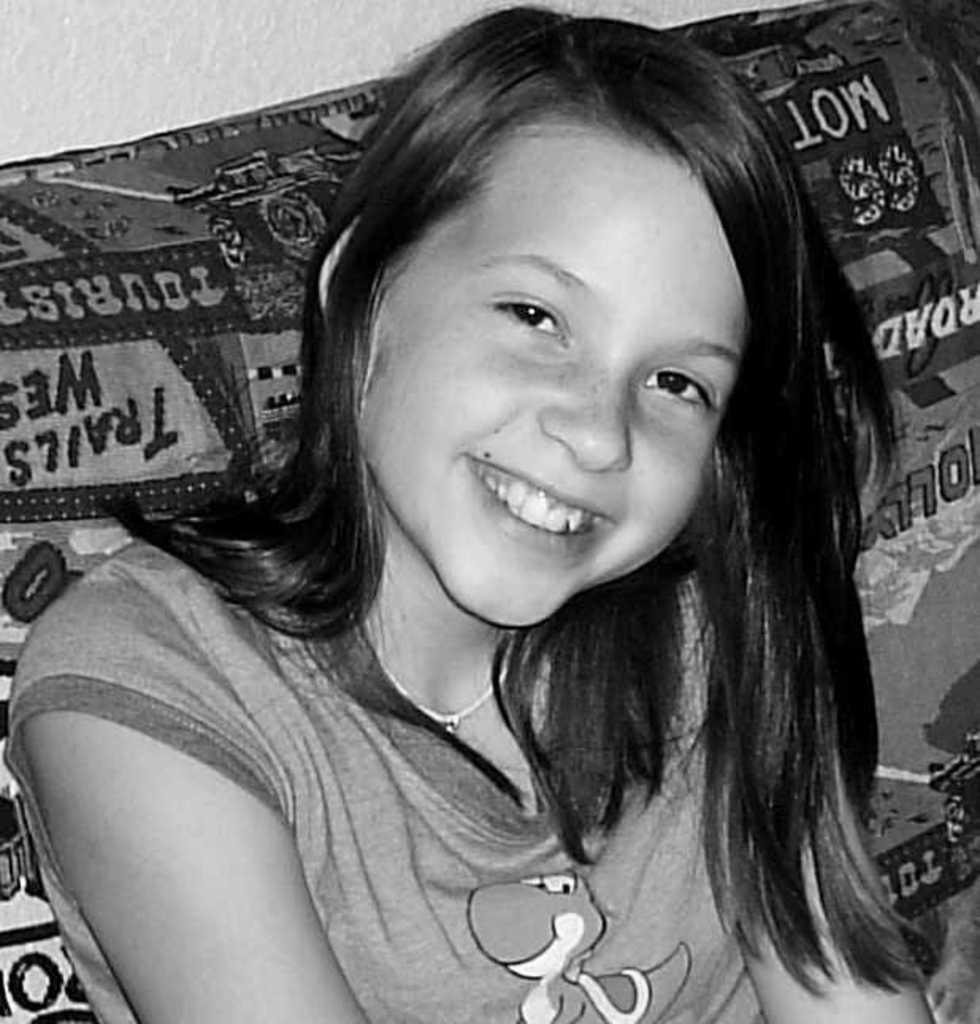What is the color scheme of the image? The image is black and white. What piece of furniture can be seen in the image? There is a couch in the image. What is the girl in the image doing? A girl is sitting on the couch. What is located at the top of the image? There is a wall at the top of the image. Can you see any worms crawling on the couch in the image? There are no worms present in the image. What type of rifle is the girl holding in the image? There is no rifle present in the image; the girl is simply sitting on the couch. 